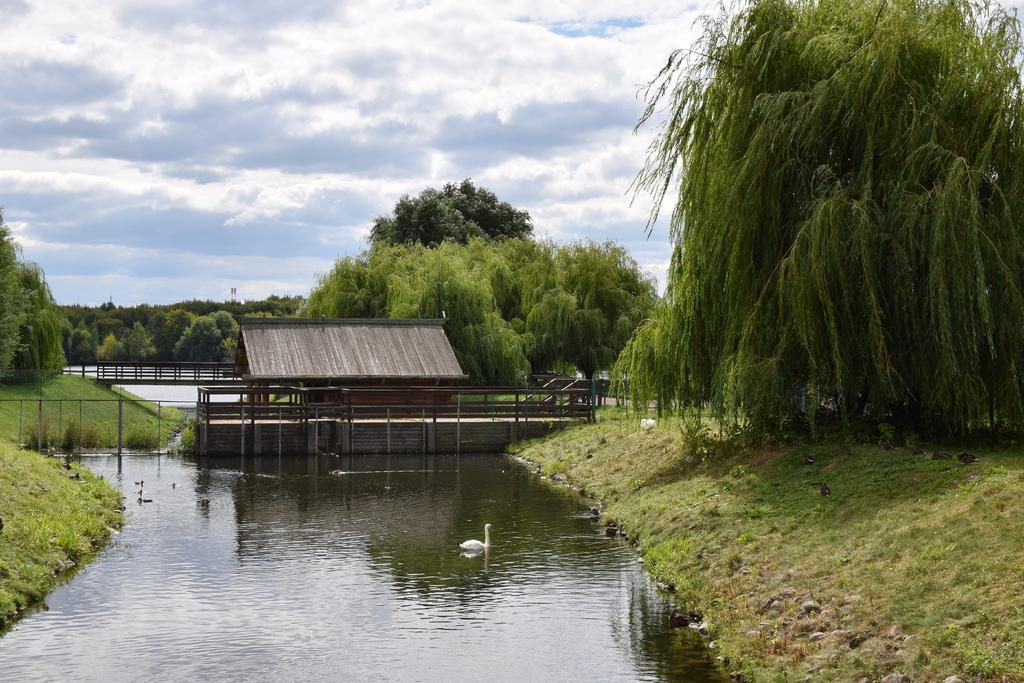Describe this image in one or two sentences. In this image, we can see a bridge and there is a shed. In the background, there are trees and at the bottom, there is a swan in the water. At the top, there are clouds in the sky. 